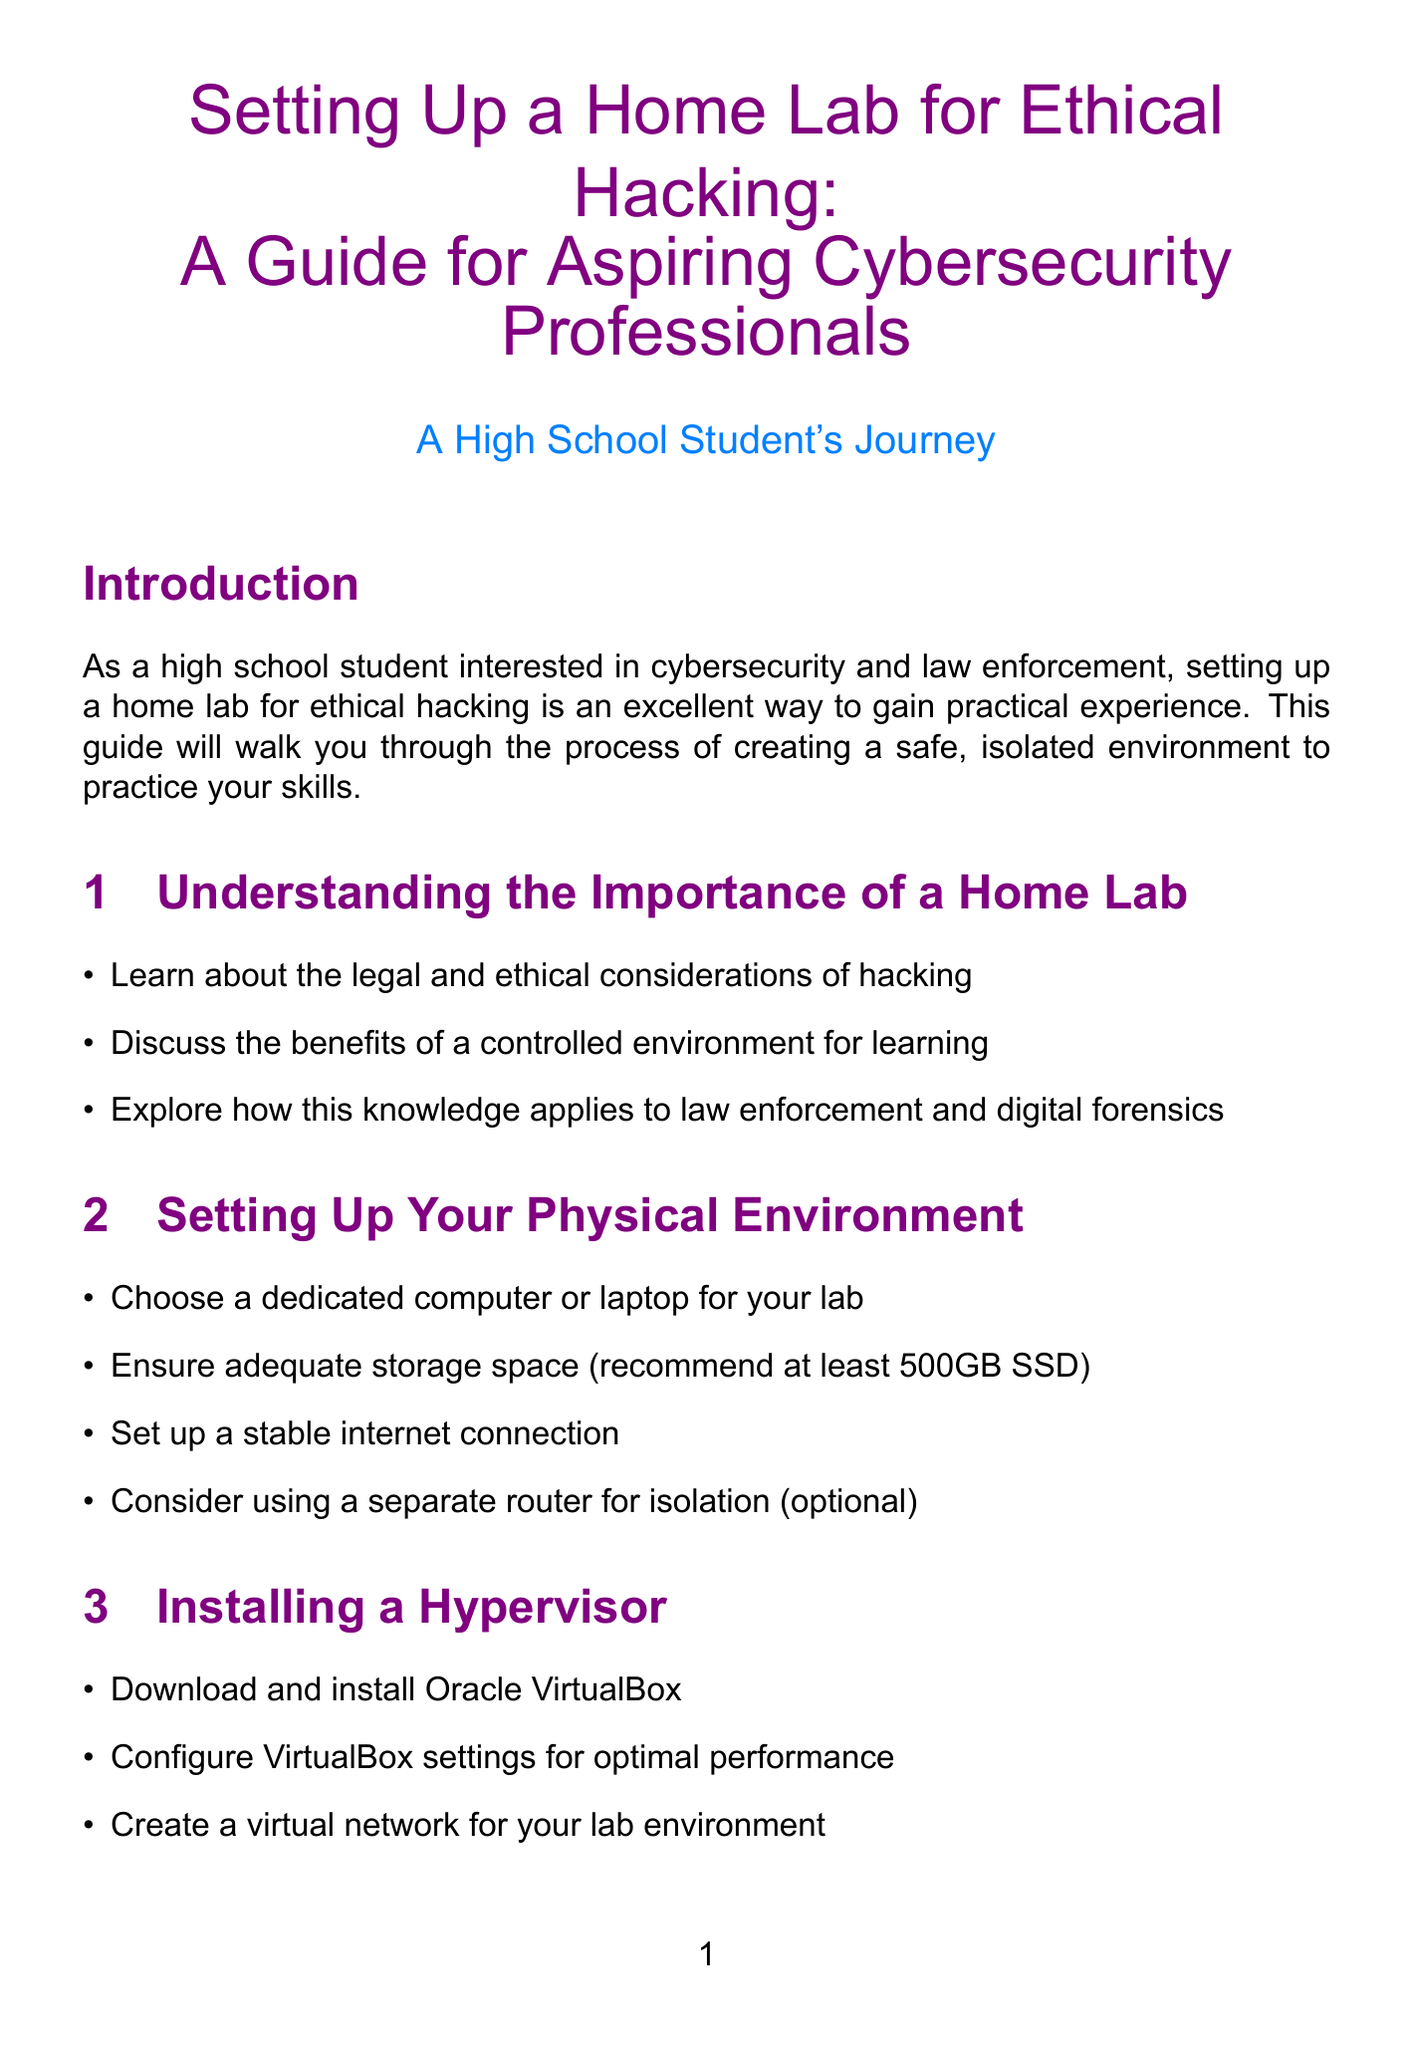What is the main focus of the guide? The guide focuses on setting up a home lab for ethical hacking for aspiring cybersecurity professionals.
Answer: Ethical hacking What is the recommended storage space for the computer? The document recommends having at least 500GB SSD for adequate storage space.
Answer: 500GB SSD Which operating system is mentioned for the target virtual machine? The document specifies Windows 10 as the target system to be set up in the virtual machine.
Answer: Windows 10 What security tool is used for network scanning? Nmap is mentioned as the tool for network scanning in the document.
Answer: Nmap What does the document suggest to ensure network isolation? The document suggests using a separate router for isolation as an optional measure.
Answer: Separate router What is one basic security measure recommended for virtual machines? The document recommends setting strong passwords for all virtual machines as a basic security measure.
Answer: Strong passwords What is the first step in the Installation of a hypervisor section? The first step mentioned is to download and install Oracle VirtualBox.
Answer: Download and install Oracle VirtualBox Which section discusses the importance of proper authorization? The section titled "Legal and Ethical Considerations" discusses the importance of obtaining proper authorization.
Answer: Legal and Ethical Considerations What is suggested for further learning in the resources section? The document suggests recommending books on ethical hacking and cybersecurity for further learning.
Answer: Books on ethical hacking and cybersecurity 